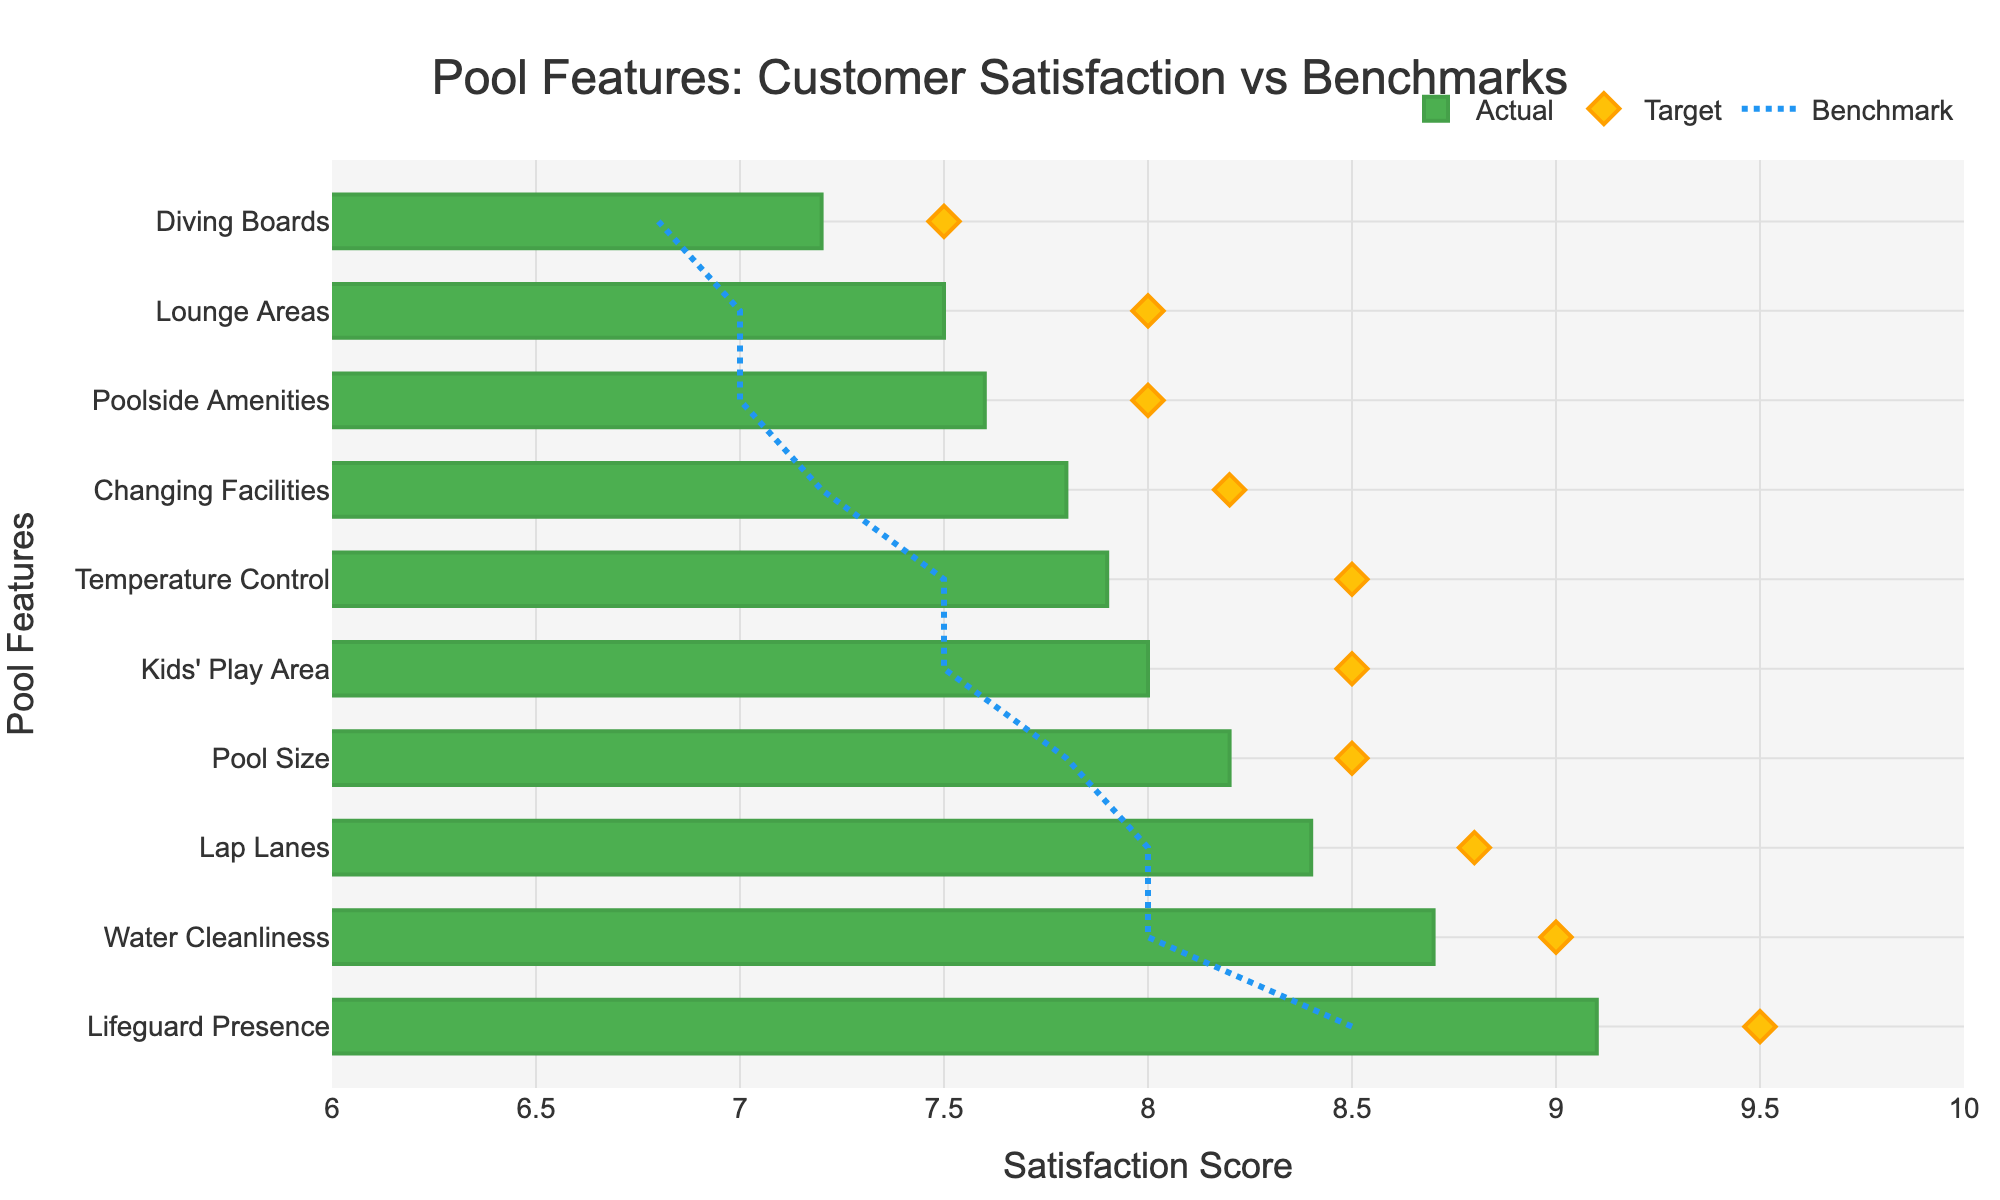How many features have satisfaction scores above the industry benchmark? We need to count how many features have actual satisfaction scores greater than their benchmarks. According to the bullet chart, the features that meet this criterion are Water Cleanliness, Temperature Control, Pool Size, Lounge Areas, Changing Facilities, Lifeguard Presence, Diving Boards, Lap Lanes, Kids' Play Area, and Poolside Amenities.
Answer: 10 Which pool feature has the highest customer satisfaction score, and what is the score? Look for the feature with the highest value on the horizontal axis (actual satisfaction score). According to the chart, Lifeguard Presence has the highest score.
Answer: Lifeguard Presence, 9.1 What is the difference between the actual score and the benchmark for the Lap Lanes feature? For Lap Lanes, subtract the benchmark score from the actual score. The actual score is 8.4, and the benchmark is 8.0, so 8.4 - 8.0 = 0.4.
Answer: 0.4 Are any features currently below their target satisfaction score? We need to compare the actual satisfaction scores of each feature to their respective target scores. Upon reviewing, all actual scores are below their targets.
Answer: All features Which features have actual satisfaction scores that are equal to or higher than their target scores? To find if any actual scores meet or exceed target scores, we compare each feature's actual score to its target score. From the chart, no feature's actual score meets or exceeds its target.
Answer: None How much higher is the customer satisfaction score for Water Cleanliness compared to Temperature Control? To find this, subtract the satisfaction score of Temperature Control from that of Water Cleanliness. The score for Water Cleanliness is 8.7 and for Temperature Control is 7.9, so 8.7 - 7.9 = 0.8.
Answer: 0.8 What is the average customer satisfaction score for the top three features? Identify the top three features by score: Lifeguard Presence (9.1), Water Cleanliness (8.7), and Lap Lanes (8.4). Add their scores and divide by 3: (9.1 + 8.7 + 8.4) / 3 = 26.2 / 3 = 8.733.
Answer: 8.733 Which feature has the smallest difference between the actual score and the benchmark? Calculate the difference between actual and benchmark for each feature, then identify the smallest one. Diving Boards has the smallest difference with an actual of 7.2 and a benchmark of 6.8, so the difference is 0.4.
Answer: Diving Boards 